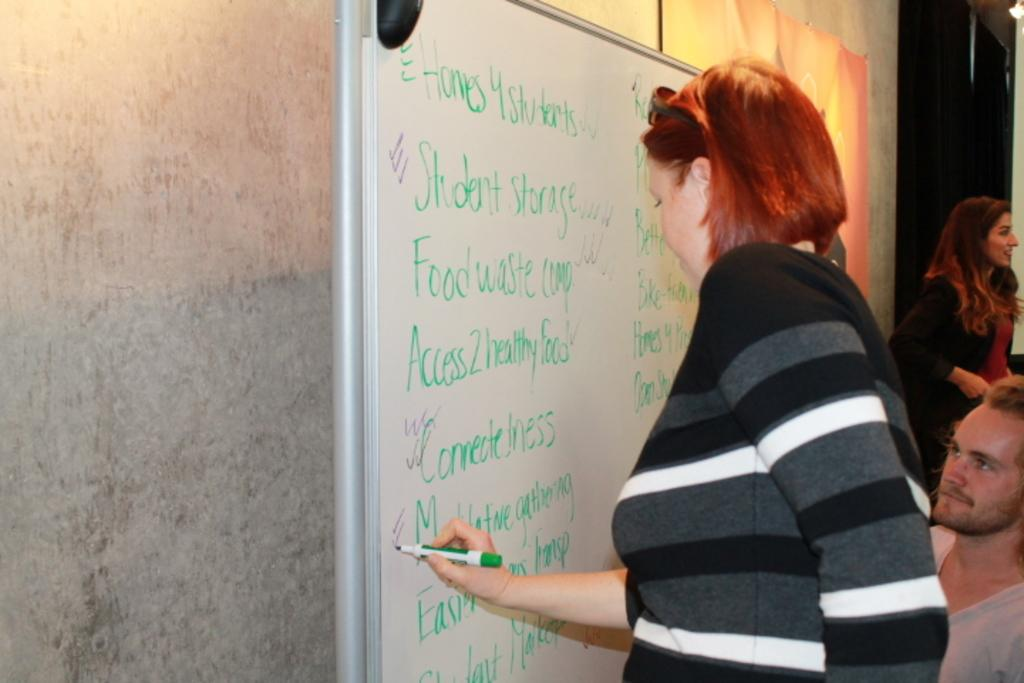<image>
Give a short and clear explanation of the subsequent image. A woman is making checkmarks next to a list of things that includes food waste. 